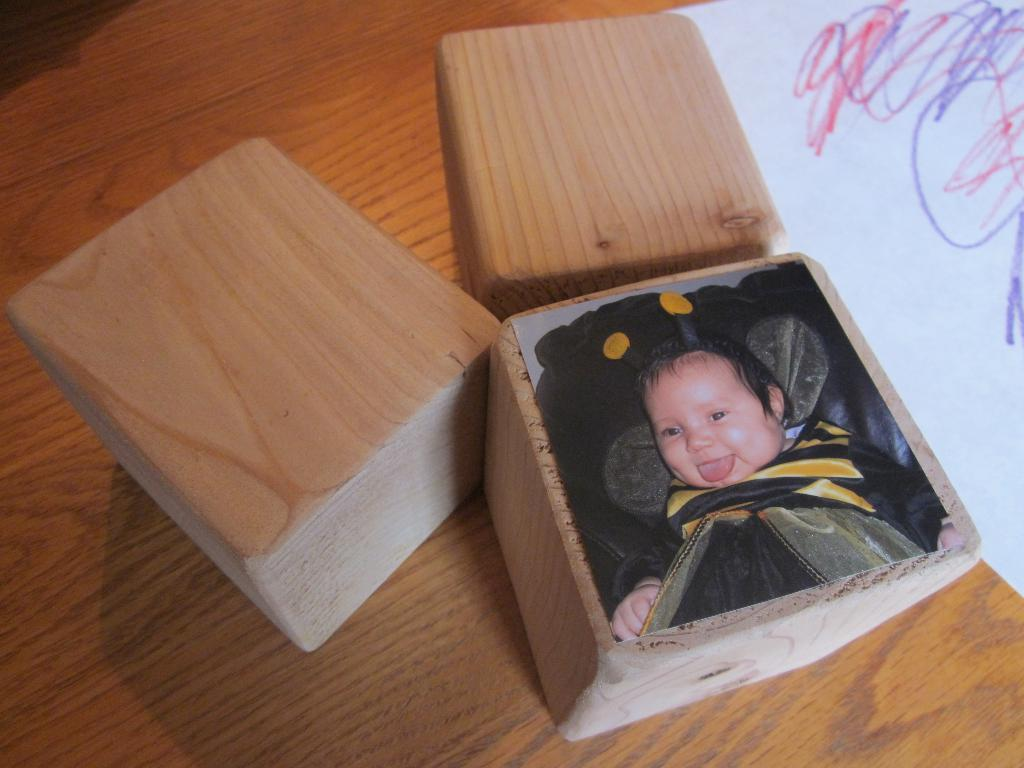What type of material is used for the objects in the image? The objects in the image are made of wood. What else can be seen on the table besides the wooden objects? There is paper and a photo of a baby smiling on the table. Can you describe the photo in the image? The photo is of a baby smiling. How far away are the horses from the wooden objects in the image? There are no horses present in the image, so it is not possible to determine their distance from the wooden objects. 